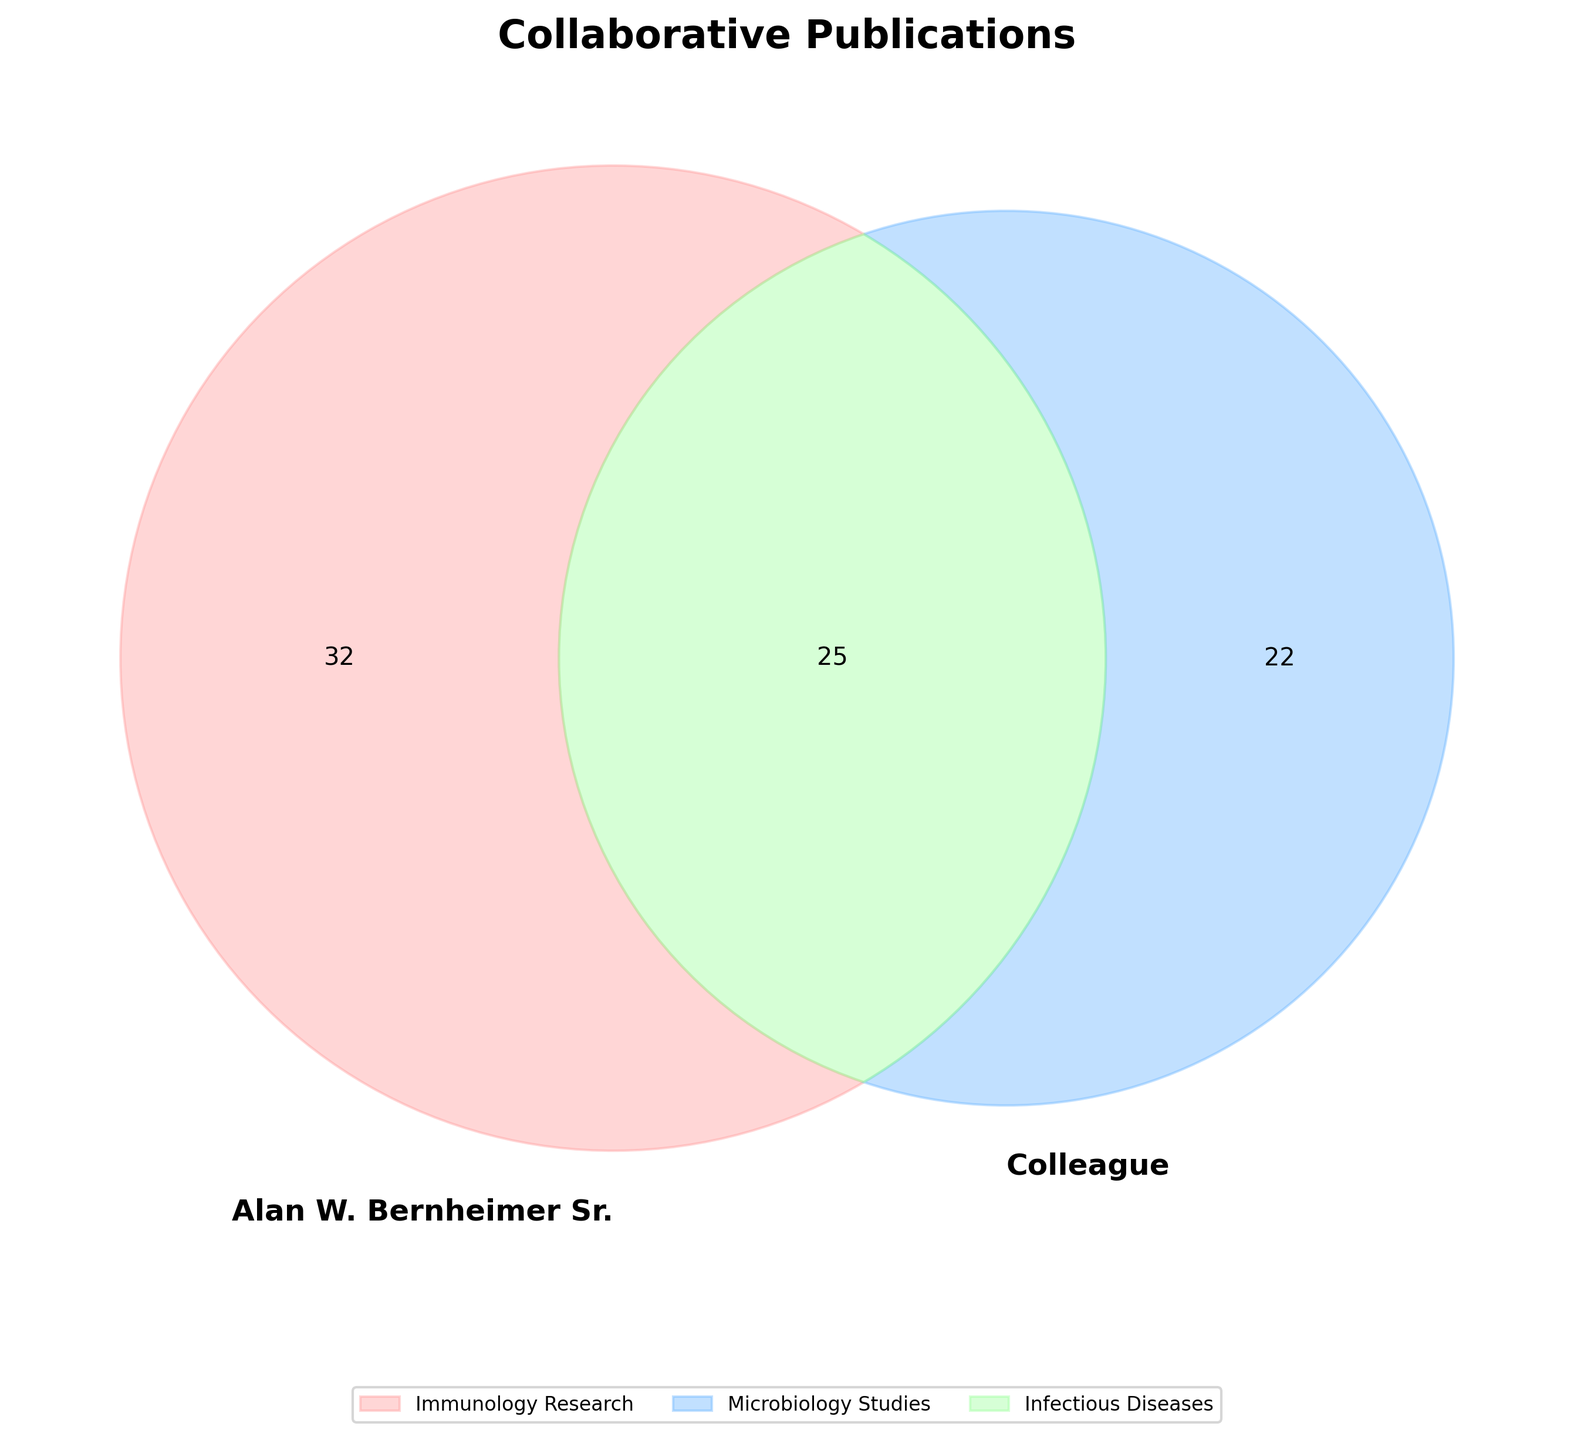What is the title of the Venn diagram? The title is located at the top of the figure in a larger font size and bold formatting. It reads "Collaborative Publications".
Answer: Collaborative Publications How many publications did Alan W. Bernheimer Sr. contribute to without collaboration? The subset representing publications exclusively by Alan W. Bernheimer Sr. can be found at (alan_total - both_total).
Answer: 47 What does the green section of the Venn diagram represent? The section colored in green represents the number of publications that were co-authored by both Alan W. Bernheimer Sr. and his colleague.
Answer: Co-authored publications How many total publications did the colleague contribute to? The subset representing publications by the colleague can be read from adding the exclusive publications by the colleague and the co-authored ones.
Answer: 47 How many exclusive publications does the colleague have? The section representing publications exclusively by the colleague can be derived by subtracting the co-authored publications from the total publications attributed to the colleague.
Answer: 30 Which section has the lowest number of publications? By comparing the numbers in each subset of the Venn diagram, identify the one with the lowest value.
Answer: Co-authored publications How many total categories are represented in the legend of the figure? At the bottom of the figure, the legend lists the categories included in the Venn diagram. Count the names.
Answer: 7 How many more publications did Alan W. Bernheimer Sr. have compared to their colleague when excluding co-authored works? Calculate the difference between the exclusive publications of Alan W. Bernheimer Sr. and his colleague.
Answer: 17 